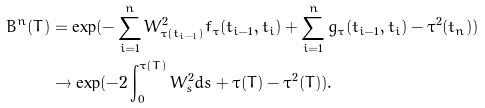Convert formula to latex. <formula><loc_0><loc_0><loc_500><loc_500>B ^ { n } ( T ) & = \exp ( - \sum _ { i = 1 } ^ { n } W _ { \tau ( t _ { i - 1 } ) } ^ { 2 } f _ { \tau } ( t _ { i - 1 } , t _ { i } ) + \sum _ { i = 1 } ^ { n } g _ { \tau } ( t _ { i - 1 } , t _ { i } ) - \tau ^ { 2 } ( t _ { n } ) ) \\ & \to \exp ( - 2 \int _ { 0 } ^ { \tau ( T ) } W _ { s } ^ { 2 } d s + \tau ( T ) - \tau ^ { 2 } ( T ) ) .</formula> 